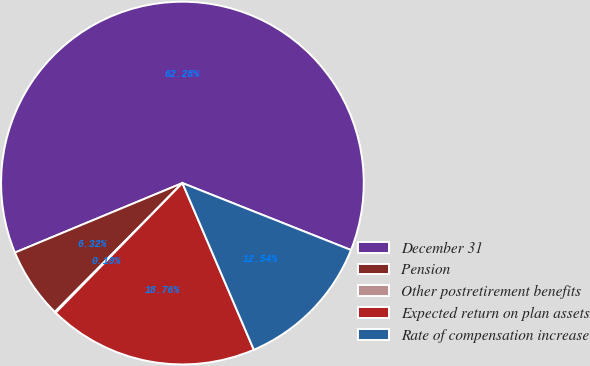Convert chart to OTSL. <chart><loc_0><loc_0><loc_500><loc_500><pie_chart><fcel>December 31<fcel>Pension<fcel>Other postretirement benefits<fcel>Expected return on plan assets<fcel>Rate of compensation increase<nl><fcel>62.28%<fcel>6.32%<fcel>0.1%<fcel>18.76%<fcel>12.54%<nl></chart> 